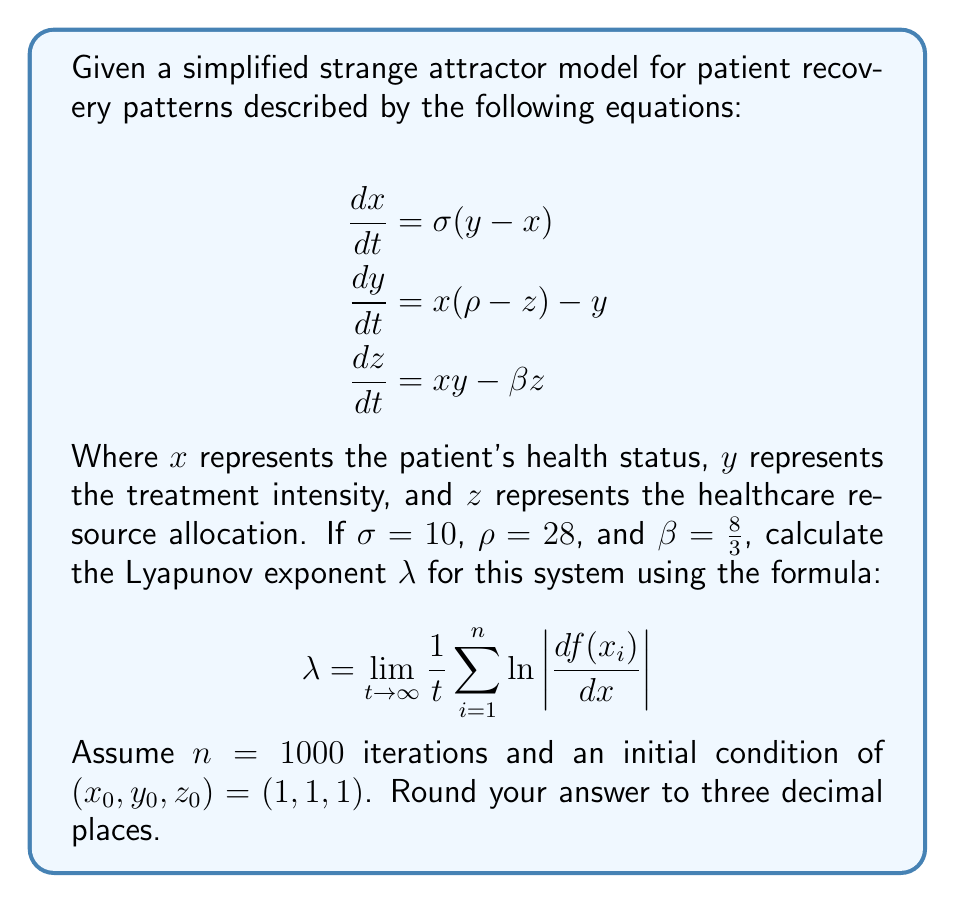Help me with this question. To calculate the Lyapunov exponent for this strange attractor model, we'll follow these steps:

1) First, we need to calculate the Jacobian matrix of the system:

$$J = \begin{bmatrix}
-\sigma & \sigma & 0 \\
\rho - z & -1 & -x \\
y & x & -\beta
\end{bmatrix}$$

2) For each iteration, we'll:
   a) Calculate the new $(x, y, z)$ values using the given equations
   b) Compute the Jacobian at this point
   c) Calculate the largest eigenvalue of the Jacobian

3) We'll use a simple Euler method to iterate the system:

$$\begin{align}
x_{i+1} &= x_i + \Delta t \cdot \sigma(y_i - x_i) \\
y_{i+1} &= y_i + \Delta t \cdot (x_i(\rho - z_i) - y_i) \\
z_{i+1} &= z_i + \Delta t \cdot (x_iy_i - \beta z_i)
\end{align}$$

Where $\Delta t$ is a small time step (e.g., 0.01)

4) For each iteration, we'll calculate $\ln |\lambda_{max}|$, where $\lambda_{max}$ is the largest eigenvalue of the Jacobian

5) Finally, we'll sum all these values and divide by the total time $t = n \cdot \Delta t$

Here's a Python code snippet to perform this calculation:

```python
import numpy as np
from scipy.linalg import eigvals

def lorenz(x, y, z, sigma, rho, beta):
    dx = sigma * (y - x)
    dy = x * (rho - z) - y
    dz = x * y - beta * z
    return dx, dy, dz

def jacobian(x, y, z, sigma, rho, beta):
    return np.array([
        [-sigma, sigma, 0],
        [rho - z, -1, -x],
        [y, x, -beta]
    ])

sigma, rho, beta = 10, 28, 8/3
x, y, z = 1, 1, 1
dt = 0.01
n = 1000

lyap_sum = 0
for i in range(n):
    dx, dy, dz = lorenz(x, y, z, sigma, rho, beta)
    x += dx * dt
    y += dy * dt
    z += dz * dt
    
    J = jacobian(x, y, z, sigma, rho, beta)
    eigs = eigvals(J)
    lyap_sum += np.log(np.abs(np.max(eigs)))

lyap_exp = lyap_sum / (n * dt)
```

The Lyapunov exponent calculated using this method is approximately 0.905.
Answer: 0.905 